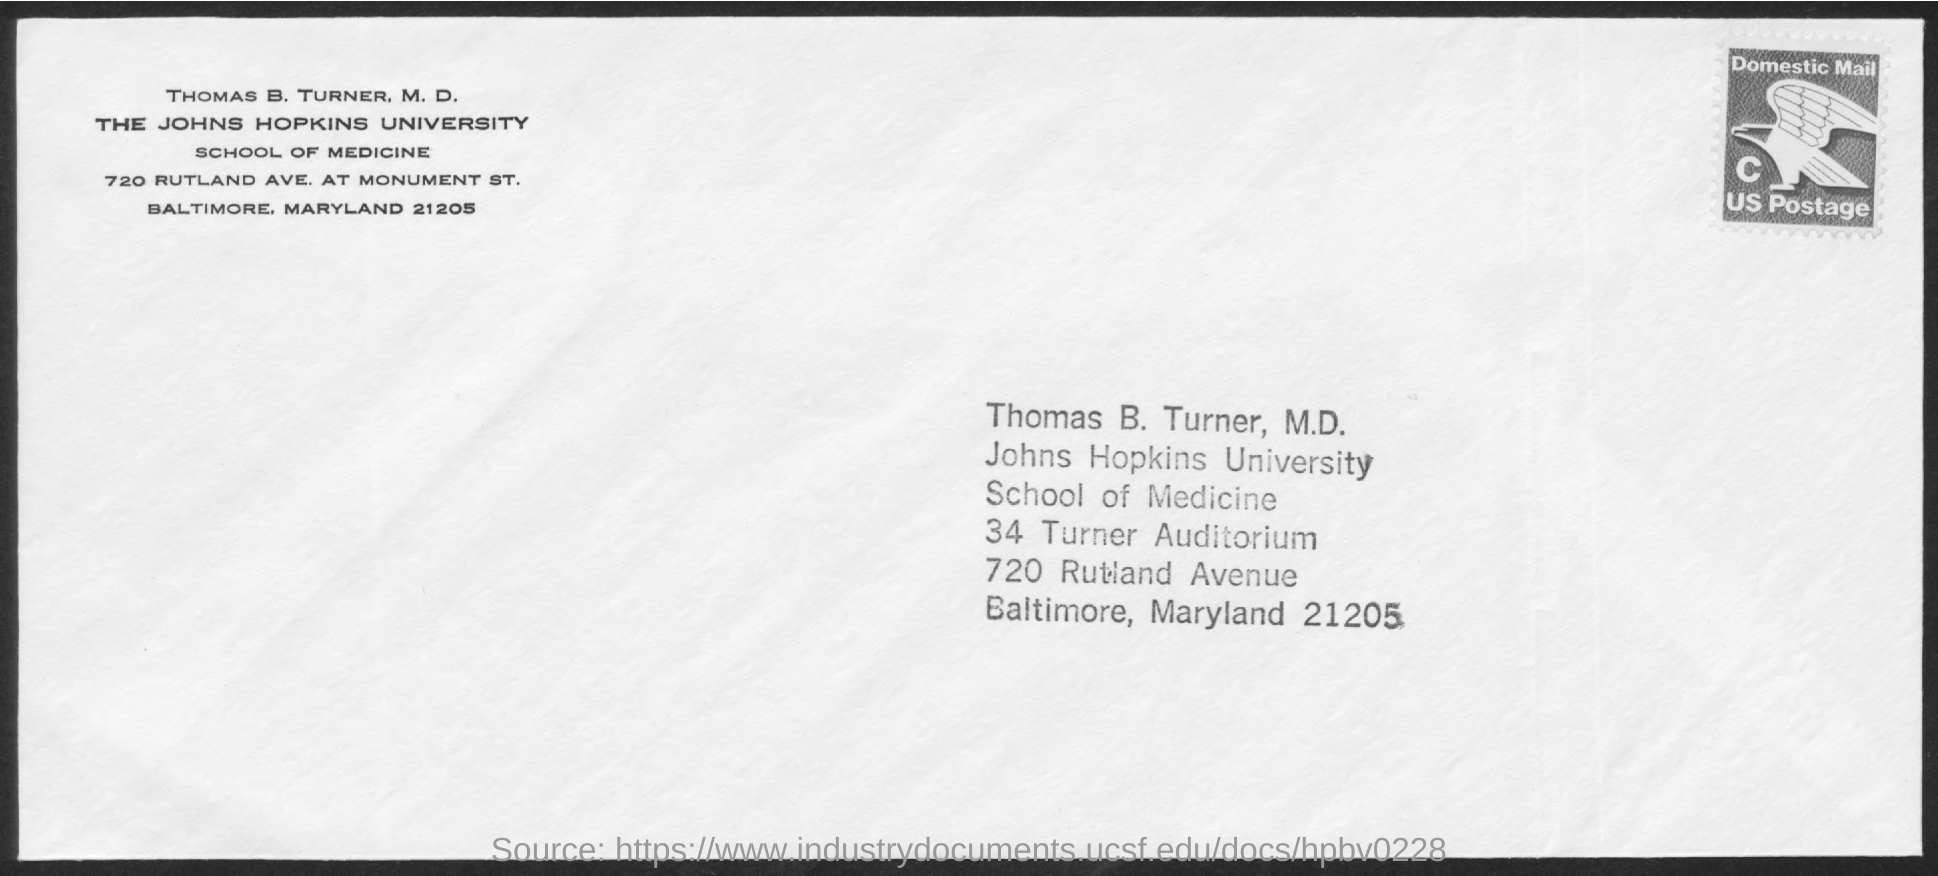Draw attention to some important aspects in this diagram. The letter addressed to Thomas B. Turner, M.D., is directed to him. 